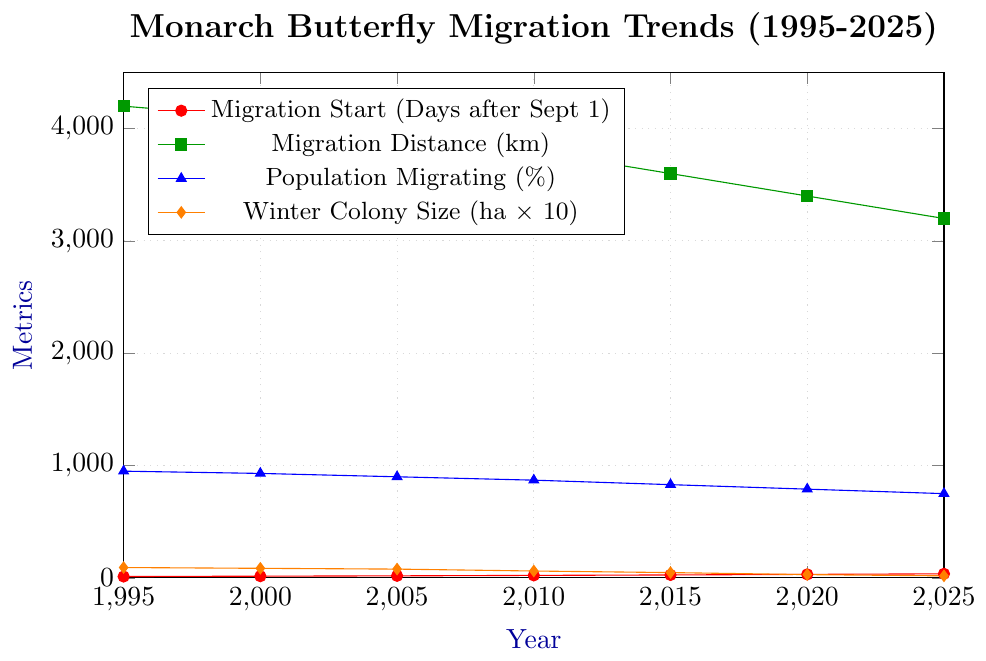What is the trend for the Average Migration Start Date over the years? The Average Migration Start Date consistently increases from 12 days in 1995 to 36 days in 2025. This shows that monarch butterflies are starting their migration progressively later every decade.
Answer: It is increasing How much has the Average Winter Colony Size decreased from 1995 to 2025? The Average Winter Colony Size in 1995 was 9.2 hectares, and it decreased to 1.8 hectares in 2025. The decrease is calculated as 9.2 - 1.8 = 7.4 hectares.
Answer: 7.4 hectares Between which consecutive years is the biggest reduction in Average Migration Distance observed? The reduction in Average Migration Distance can be observed between consecutive years: from 1995 to 2000 (4200 to 4100), from 2000 to 2005 (4100 to 3950), from 2005 to 2010 (3950 to 3800), from 2010 to 2015 (3800 to 3600), from 2015 to 2020 (3600 to 3400), and from 2020 to 2025 (3400 to 3200).
The largest decrease is between 2010 and 2015, which is 3800 - 3600 = 200 km.
Answer: 2010 to 2015 How much did the Percentage of Population Migrating change from 1995 to 2025 in percentage points? The Percentage of Population Migrating decreased from 95% in 1995 to 75% in 2025. The change is calculated as 95 - 75 = 20 percentage points.
Answer: 20 percentage points Which year had the smallest Average Winter Colony Size? Among the plotted years, 2025 had the smallest Average Winter Colony Size at 1.8 hectares.
Answer: 2025 What is the overall trend in the Average Migration Distance? The Average Migration Distance shows a decreasing trend from 4200 km in 1995 to 3200 km in 2025.
Answer: It is decreasing From 1995 to 2025, in which year has the monarch butterfly migration start date increased the most compared to the previous year? The increase per five-year step is noted as follows: from 1995 to 2000, it increases by 3 days; from 2000 to 2005, it increases by 3 days; from 2005 to 2010, it increases by 4 days; from 2010 to 2015, it increases by 4 days; from 2015 to 2020, it increases by 5 days; and from 2020 to 2025, it increases by 5 days. Thus, the largest increases are from 2015 to 2020 and from 2020 to 2025.
Answer: 2015 to 2020 and 2020 to 2025 What is the average of Average Migration Start Date across all years provided? The Average Migration Start Dates are 12, 15, 18, 22, 26, 31, and 36 days. Summing these values gives 160. We have 7 years, so the average is 160/7 ≈ 22.86 days.
Answer: 22.86 days 